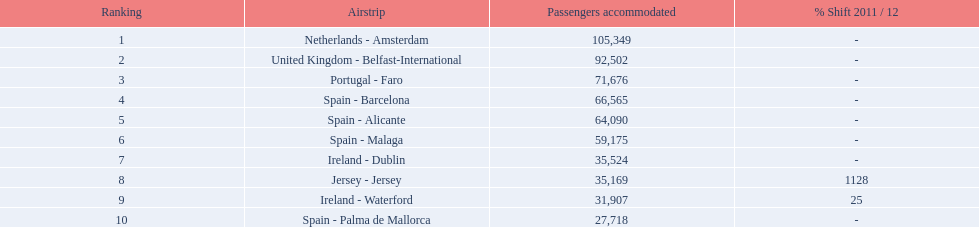What is the best rank? 1. What is the airport? Netherlands - Amsterdam. 